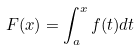<formula> <loc_0><loc_0><loc_500><loc_500>F ( x ) = \int _ { a } ^ { x } f ( t ) d t</formula> 